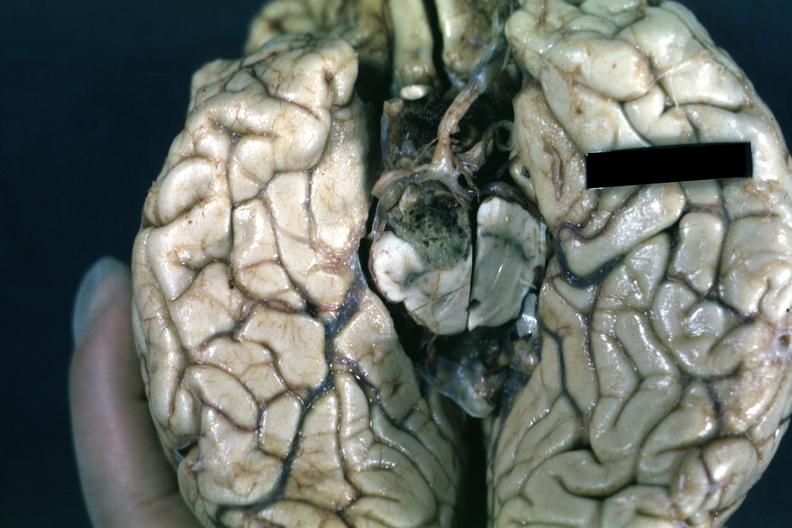what is present?
Answer the question using a single word or phrase. Pituitary 